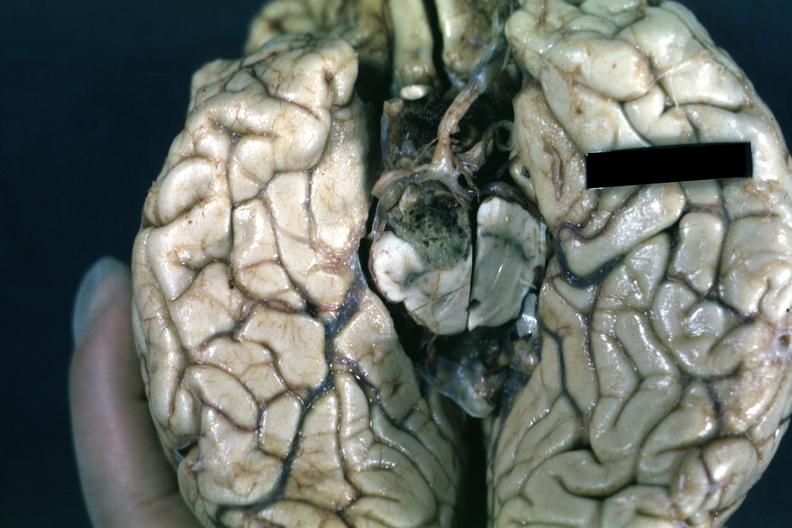what is present?
Answer the question using a single word or phrase. Pituitary 